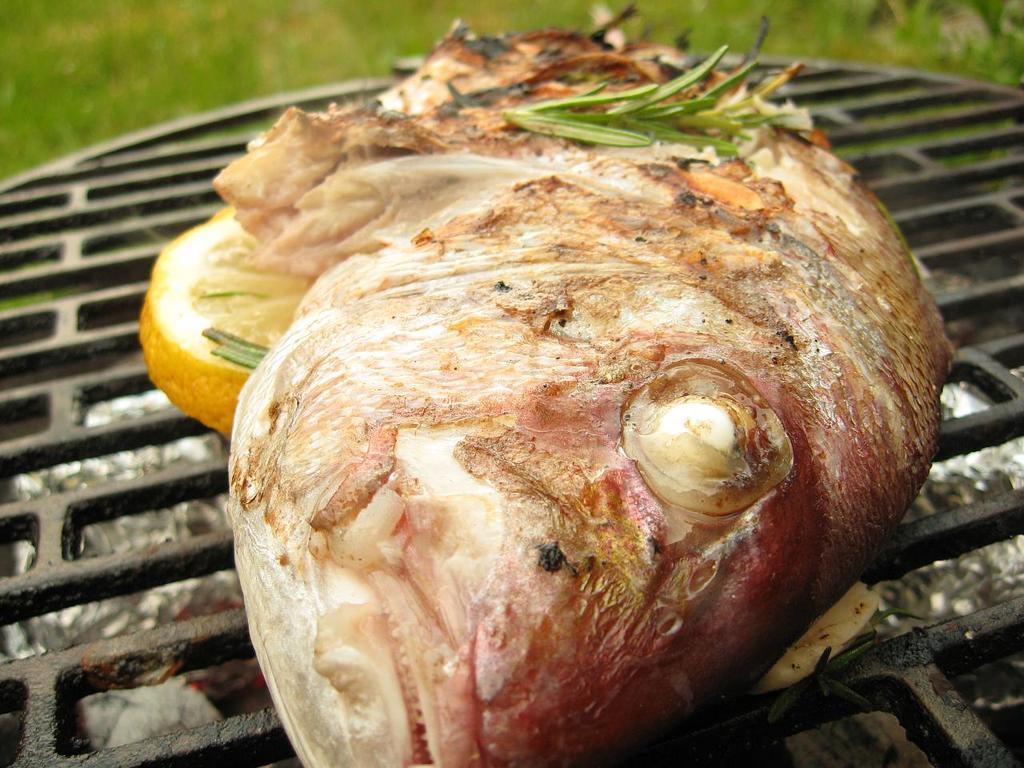Could you give a brief overview of what you see in this image? In this image I can see the food on the grill. I can see the food is in cream, yellow, green and red color. In the background I can see the plants. 